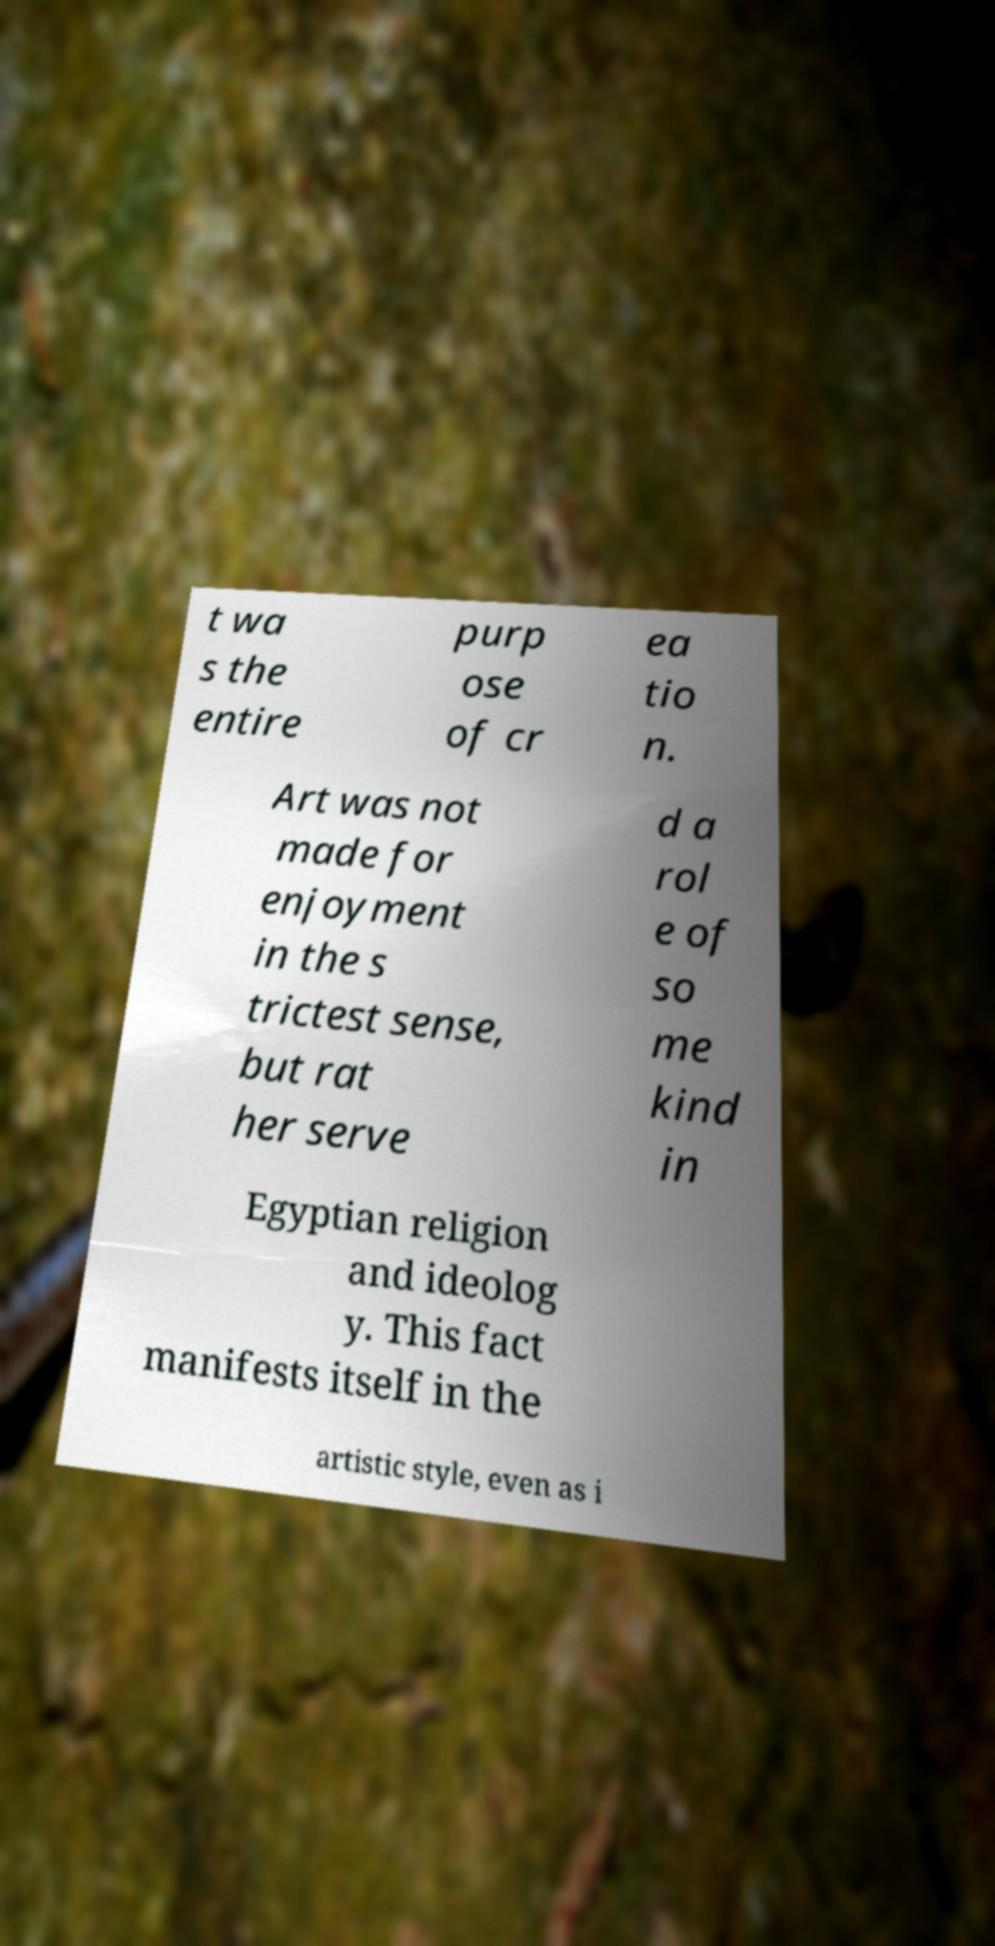Please read and relay the text visible in this image. What does it say? t wa s the entire purp ose of cr ea tio n. Art was not made for enjoyment in the s trictest sense, but rat her serve d a rol e of so me kind in Egyptian religion and ideolog y. This fact manifests itself in the artistic style, even as i 